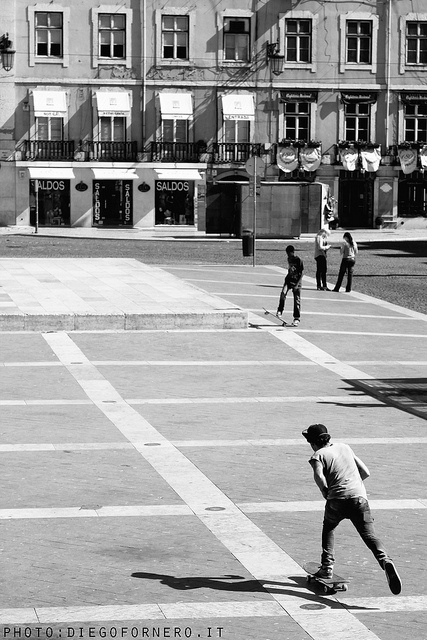Describe the objects in this image and their specific colors. I can see people in lightgray, black, darkgray, and gray tones, people in lightgray, black, gray, and darkgray tones, people in lightgray, black, gray, and darkgray tones, skateboard in lightgray, black, darkgray, and gray tones, and people in lightgray, black, and gray tones in this image. 